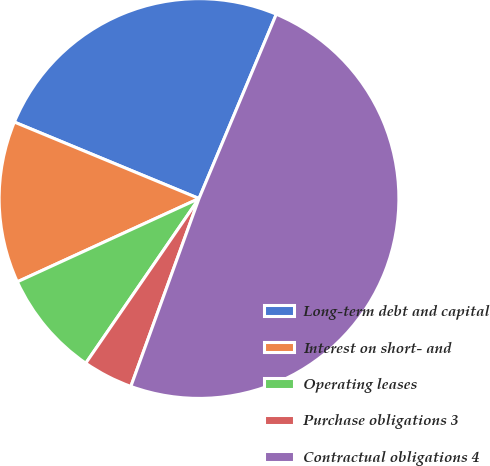<chart> <loc_0><loc_0><loc_500><loc_500><pie_chart><fcel>Long-term debt and capital<fcel>Interest on short- and<fcel>Operating leases<fcel>Purchase obligations 3<fcel>Contractual obligations 4<nl><fcel>25.07%<fcel>13.09%<fcel>8.57%<fcel>4.05%<fcel>49.22%<nl></chart> 